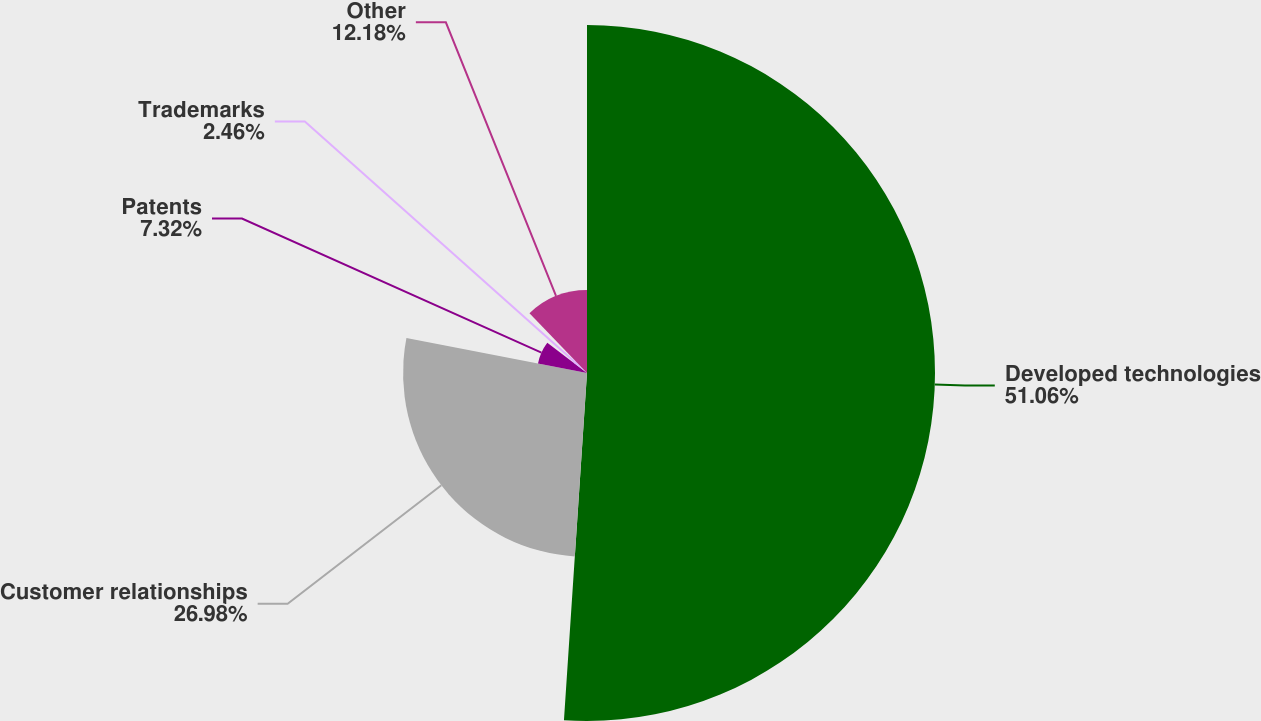<chart> <loc_0><loc_0><loc_500><loc_500><pie_chart><fcel>Developed technologies<fcel>Customer relationships<fcel>Patents<fcel>Trademarks<fcel>Other<nl><fcel>51.05%<fcel>26.98%<fcel>7.32%<fcel>2.46%<fcel>12.18%<nl></chart> 